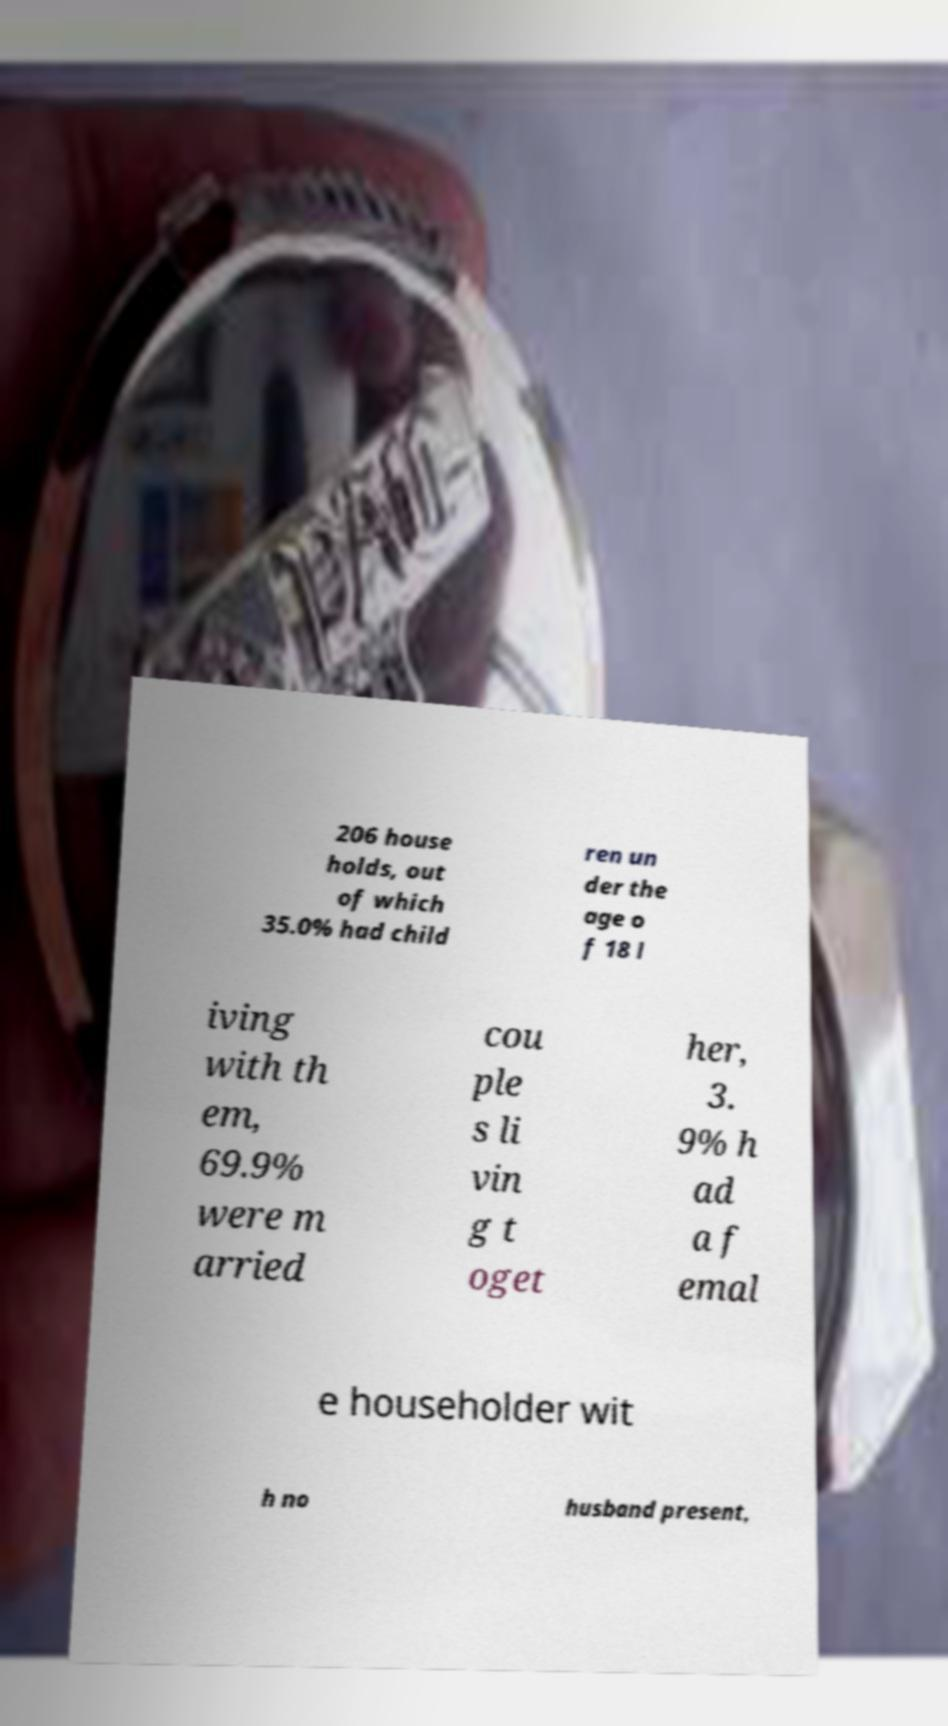There's text embedded in this image that I need extracted. Can you transcribe it verbatim? 206 house holds, out of which 35.0% had child ren un der the age o f 18 l iving with th em, 69.9% were m arried cou ple s li vin g t oget her, 3. 9% h ad a f emal e householder wit h no husband present, 